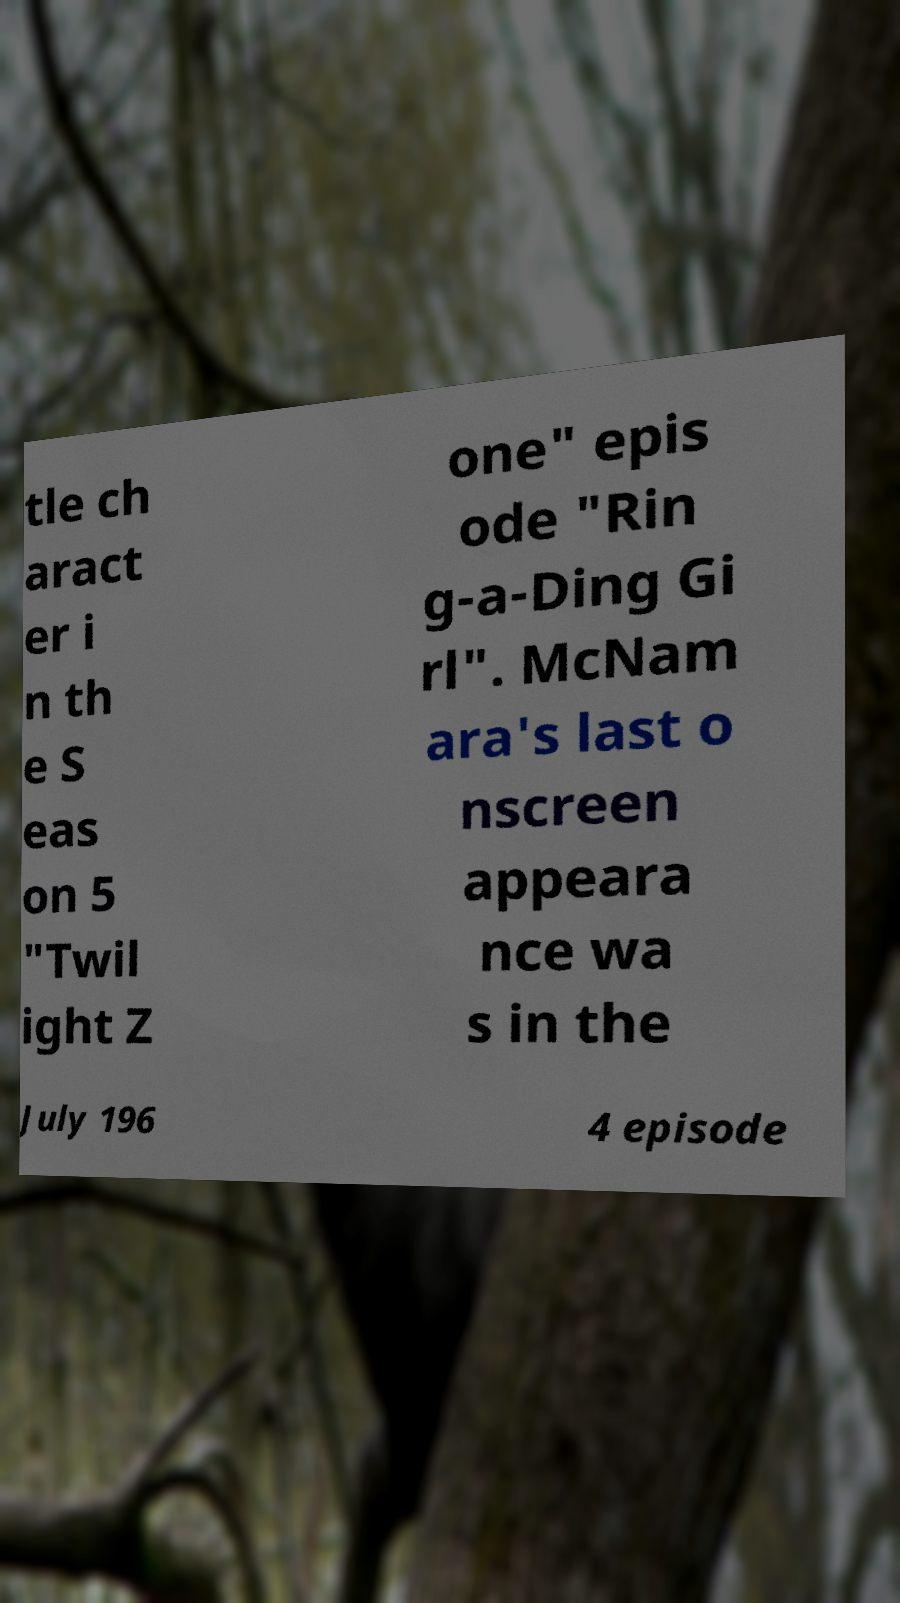Please identify and transcribe the text found in this image. tle ch aract er i n th e S eas on 5 "Twil ight Z one" epis ode "Rin g-a-Ding Gi rl". McNam ara's last o nscreen appeara nce wa s in the July 196 4 episode 